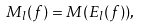Convert formula to latex. <formula><loc_0><loc_0><loc_500><loc_500>M _ { l } ( f ) = M ( E _ { l } ( f ) ) ,</formula> 